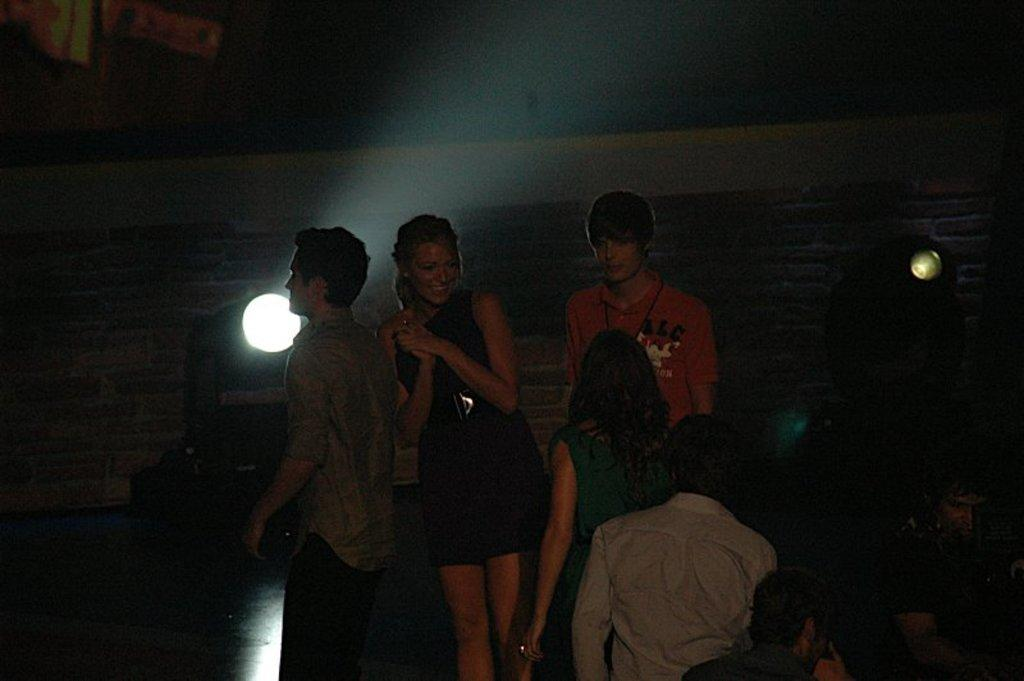What are the people in the image doing? There are persons standing and sitting in the image. Can you describe the woman in the center of the image? There is a woman standing and smiling in the center of the image. What can be seen in the background of the image? There is a wall and lights in the background of the image. What type of pollution is visible in the image? There is no visible pollution in the image. Can you describe the flight path of the birds in the image? There are no birds present in the image. 